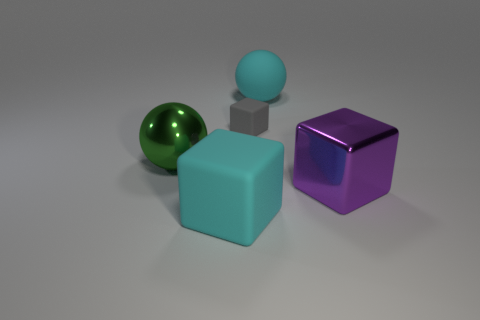What could be the possible uses for these objects? These objects could serve various functions depending on their material and context. They might be simplistic models for a 3D rendering software tutorial, props in a visual effects studio, or even toys if they are made of a safe material for children. 